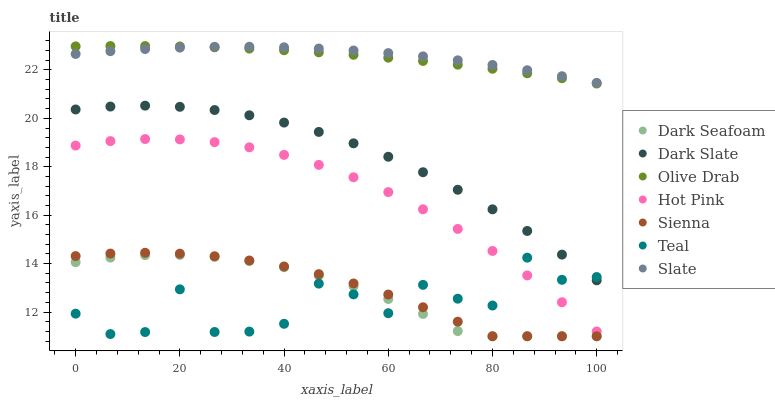Does Teal have the minimum area under the curve?
Answer yes or no. Yes. Does Slate have the maximum area under the curve?
Answer yes or no. Yes. Does Hot Pink have the minimum area under the curve?
Answer yes or no. No. Does Hot Pink have the maximum area under the curve?
Answer yes or no. No. Is Olive Drab the smoothest?
Answer yes or no. Yes. Is Teal the roughest?
Answer yes or no. Yes. Is Hot Pink the smoothest?
Answer yes or no. No. Is Hot Pink the roughest?
Answer yes or no. No. Does Sienna have the lowest value?
Answer yes or no. Yes. Does Hot Pink have the lowest value?
Answer yes or no. No. Does Olive Drab have the highest value?
Answer yes or no. Yes. Does Hot Pink have the highest value?
Answer yes or no. No. Is Dark Seafoam less than Slate?
Answer yes or no. Yes. Is Dark Slate greater than Hot Pink?
Answer yes or no. Yes. Does Dark Slate intersect Teal?
Answer yes or no. Yes. Is Dark Slate less than Teal?
Answer yes or no. No. Is Dark Slate greater than Teal?
Answer yes or no. No. Does Dark Seafoam intersect Slate?
Answer yes or no. No. 